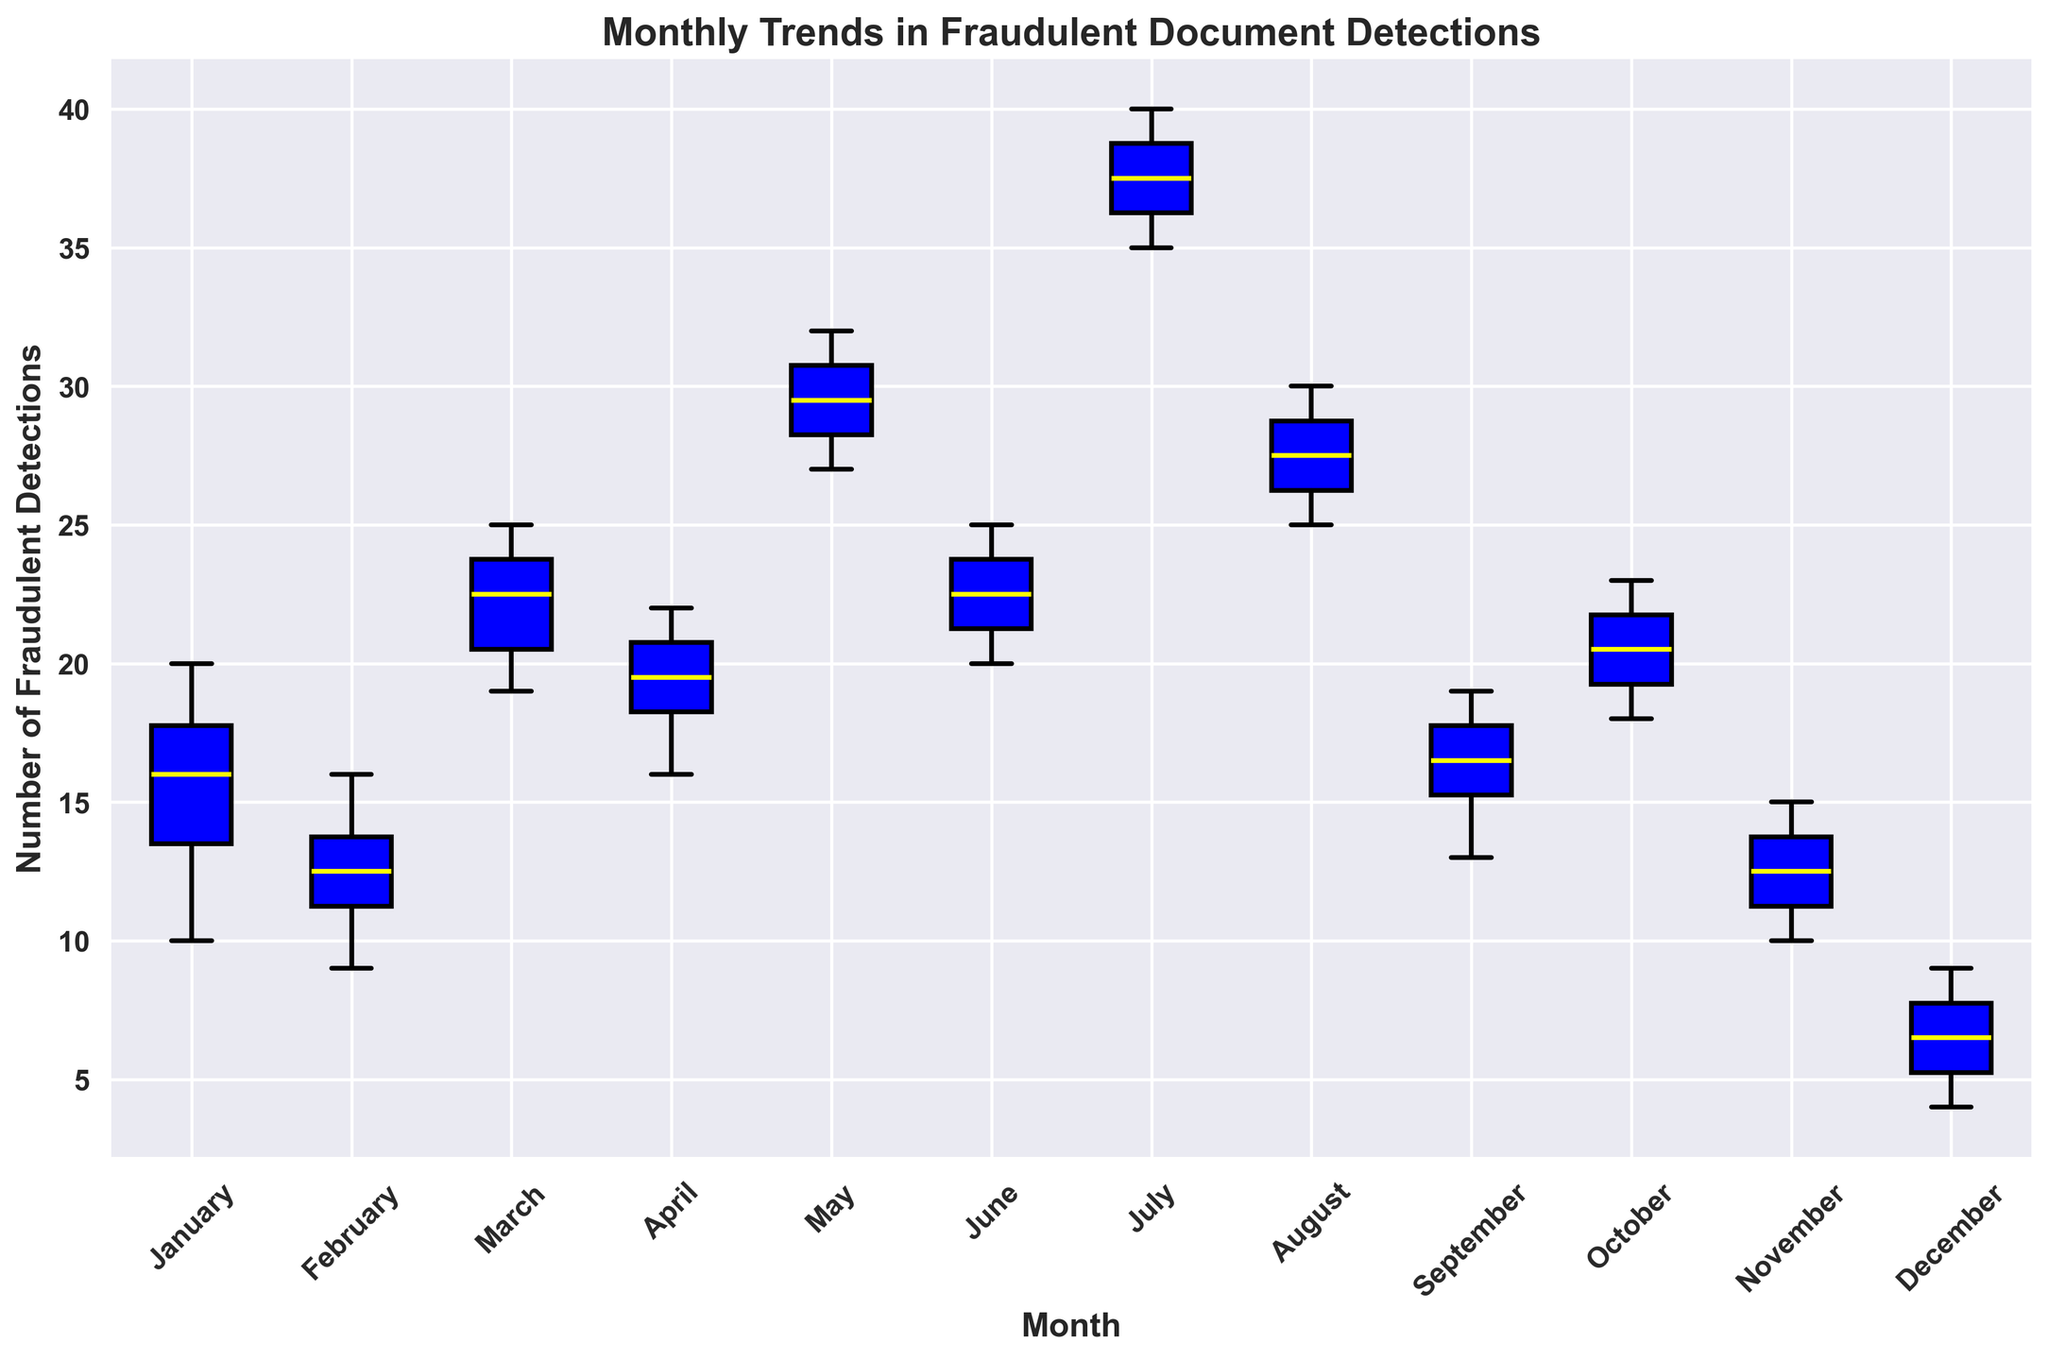Which month has the highest median number of fraudulent detections? Observe the median lines (yellow) within each box. July's median line is at the highest position compared to other months.
Answer: July Which month has the lowest interquartile range of fraudulent detections? The interquartile range (IQR) is represented by the height of the box. December has the lowest IQR because its box is the shortest.
Answer: December How does the median number of fraudulent detections in May compare to that in February? Compare the yellow median lines for May and February. May's median is higher than February's.
Answer: May's median is higher Which months have outliers in the number of fraudulent detections? Look for the red markers outside the whiskers. No month has outliers visible.
Answer: None What is the trend in the median number of fraudulent detections from January to December? Trace the progression of the median lines (yellow) from January to December; they show variability with peaks in March, May, and July.
Answer: Variable trend with peaks in March, May, and July In which month is the range (difference between maximum and minimum) of fraudulent detections the greatest? The range is indicated by the total length of the whiskers. July has the longest whiskers.
Answer: July Which month shows a significant increase in the median number of fraudulent detections compared to April? Compare April's median line to the following months’. May shows a significant increase.
Answer: May Is there a noticeable drop in the median number of fraudulent detections in any month following a peak? Observing the median lines, there's a noticeable drop from July to August.
Answer: Yes, from July to August What can be inferred about the monthly variability (spread) of fraudulent detections? Compare the sizes of the boxes and whiskers. Variability changes month to month with December having the least spread and July the most.
Answer: Monthly variability changes, highest in July and lowest in December Which month has the median closest to 10 fraudulent detections? Compare the median lines to the value of 10. November's median is the closest.
Answer: November 